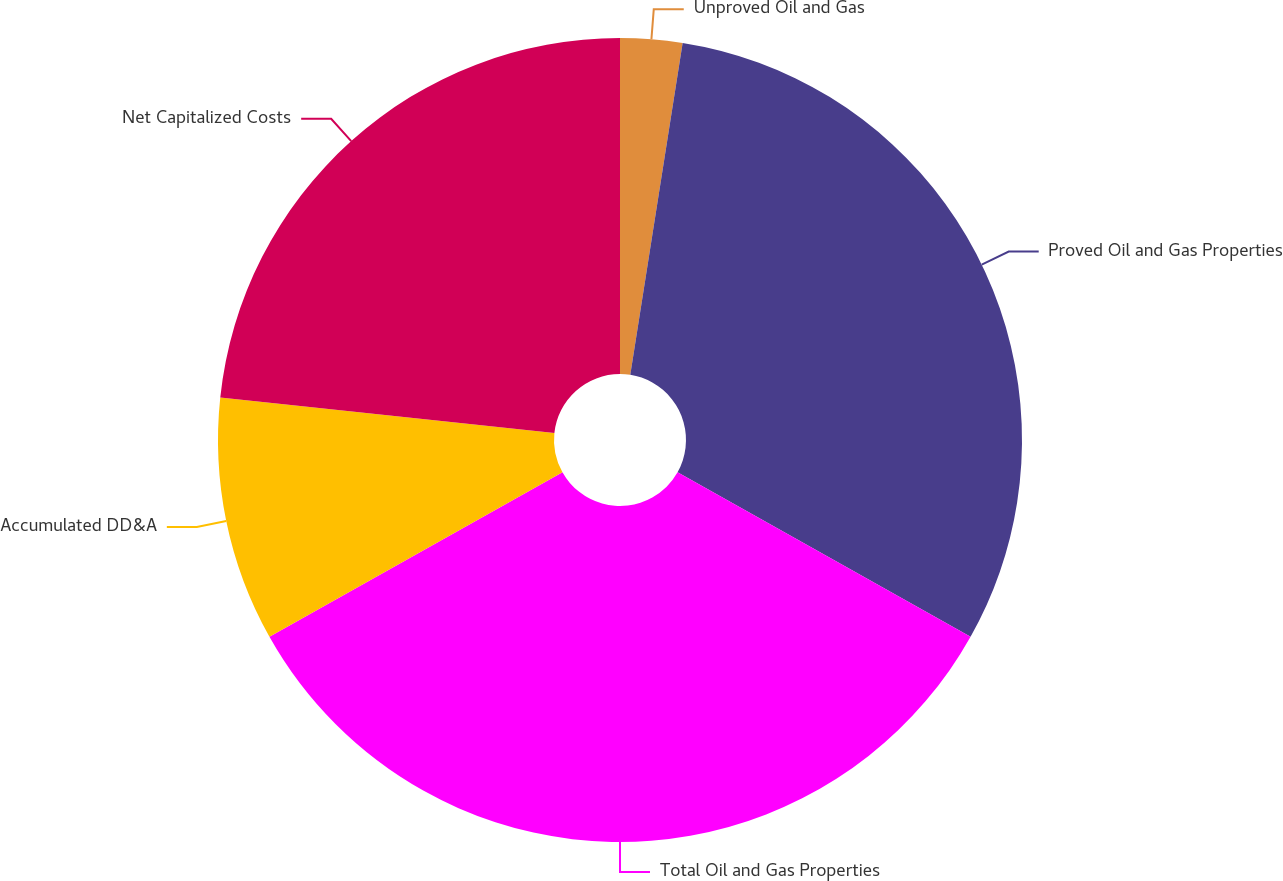<chart> <loc_0><loc_0><loc_500><loc_500><pie_chart><fcel>Unproved Oil and Gas<fcel>Proved Oil and Gas Properties<fcel>Total Oil and Gas Properties<fcel>Accumulated DD&A<fcel>Net Capitalized Costs<nl><fcel>2.49%<fcel>30.65%<fcel>33.72%<fcel>9.83%<fcel>23.31%<nl></chart> 